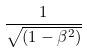Convert formula to latex. <formula><loc_0><loc_0><loc_500><loc_500>\frac { 1 } { \sqrt { ( 1 - \beta ^ { 2 } ) } }</formula> 